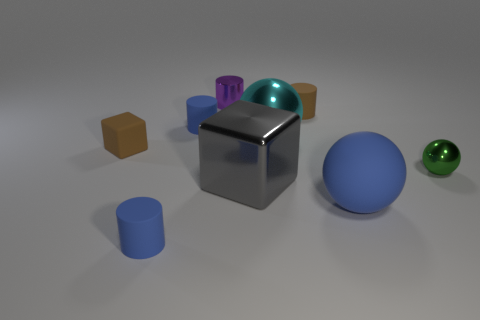How many things are cyan metallic things or small metallic things?
Your answer should be very brief. 3. How many other things are the same color as the big matte object?
Offer a very short reply. 2. There is a rubber thing that is the same size as the gray metal cube; what is its shape?
Offer a very short reply. Sphere. There is a block that is behind the green ball; what color is it?
Offer a very short reply. Brown. What number of things are either big cyan things that are to the right of the brown rubber block or tiny rubber objects that are behind the big rubber thing?
Make the answer very short. 4. Is the brown rubber cube the same size as the gray metallic thing?
Give a very brief answer. No. How many cylinders are small metal things or blue rubber objects?
Offer a terse response. 3. What number of objects are in front of the cyan metallic ball and on the right side of the large cyan thing?
Provide a succinct answer. 2. There is a matte cube; is its size the same as the metal object that is in front of the small metal ball?
Ensure brevity in your answer.  No. There is a sphere that is in front of the metal ball on the right side of the blue rubber ball; are there any rubber cylinders in front of it?
Provide a succinct answer. Yes. 